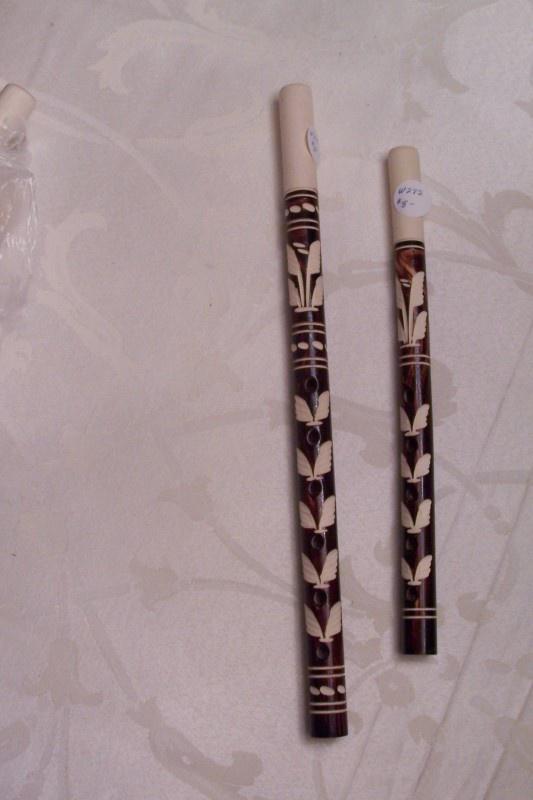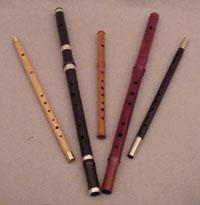The first image is the image on the left, the second image is the image on the right. Assess this claim about the two images: "One image shows at least three flute items fanned out, with ends together at one end.". Correct or not? Answer yes or no. Yes. The first image is the image on the left, the second image is the image on the right. Assess this claim about the two images: "There are at least four recorders.". Correct or not? Answer yes or no. Yes. 